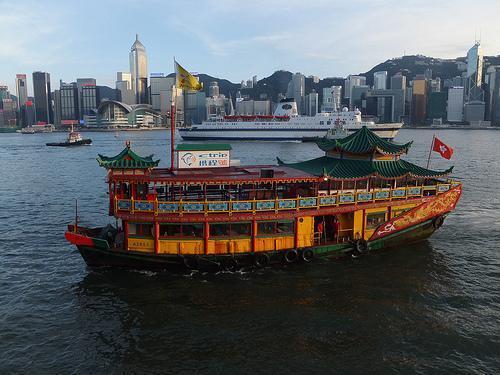How many flags are on the main boat?
Give a very brief answer. 2. 